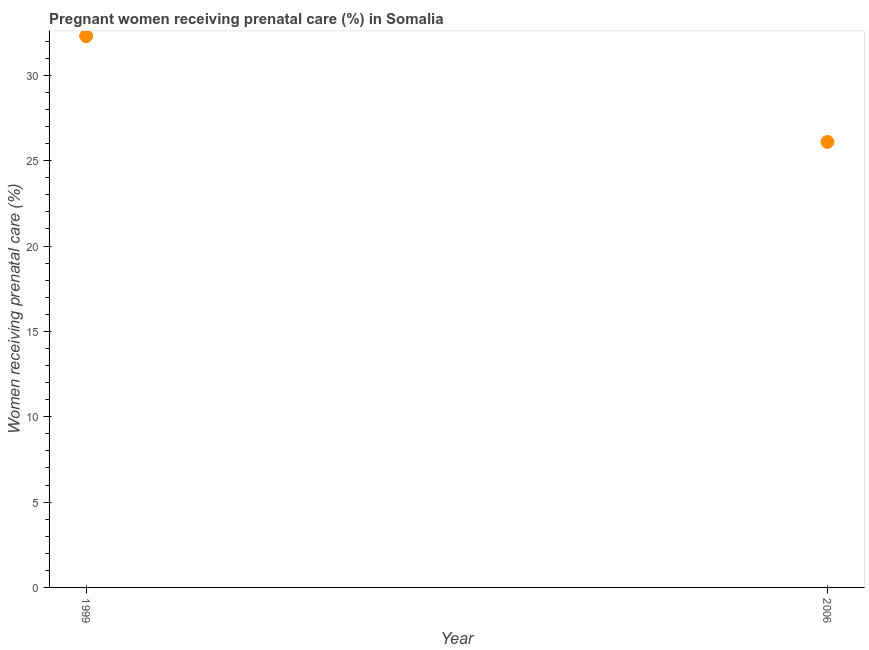What is the percentage of pregnant women receiving prenatal care in 1999?
Offer a very short reply. 32.3. Across all years, what is the maximum percentage of pregnant women receiving prenatal care?
Your answer should be very brief. 32.3. Across all years, what is the minimum percentage of pregnant women receiving prenatal care?
Give a very brief answer. 26.1. In which year was the percentage of pregnant women receiving prenatal care minimum?
Your answer should be very brief. 2006. What is the sum of the percentage of pregnant women receiving prenatal care?
Ensure brevity in your answer.  58.4. What is the difference between the percentage of pregnant women receiving prenatal care in 1999 and 2006?
Provide a short and direct response. 6.2. What is the average percentage of pregnant women receiving prenatal care per year?
Ensure brevity in your answer.  29.2. What is the median percentage of pregnant women receiving prenatal care?
Provide a succinct answer. 29.2. In how many years, is the percentage of pregnant women receiving prenatal care greater than 27 %?
Your answer should be compact. 1. What is the ratio of the percentage of pregnant women receiving prenatal care in 1999 to that in 2006?
Your answer should be very brief. 1.24. Is the percentage of pregnant women receiving prenatal care in 1999 less than that in 2006?
Offer a very short reply. No. Does the percentage of pregnant women receiving prenatal care monotonically increase over the years?
Offer a terse response. No. How many dotlines are there?
Make the answer very short. 1. How many years are there in the graph?
Offer a very short reply. 2. Are the values on the major ticks of Y-axis written in scientific E-notation?
Make the answer very short. No. Does the graph contain grids?
Ensure brevity in your answer.  No. What is the title of the graph?
Keep it short and to the point. Pregnant women receiving prenatal care (%) in Somalia. What is the label or title of the Y-axis?
Keep it short and to the point. Women receiving prenatal care (%). What is the Women receiving prenatal care (%) in 1999?
Provide a short and direct response. 32.3. What is the Women receiving prenatal care (%) in 2006?
Your response must be concise. 26.1. What is the difference between the Women receiving prenatal care (%) in 1999 and 2006?
Give a very brief answer. 6.2. What is the ratio of the Women receiving prenatal care (%) in 1999 to that in 2006?
Your answer should be very brief. 1.24. 